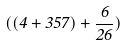Convert formula to latex. <formula><loc_0><loc_0><loc_500><loc_500>( ( 4 + 3 5 7 ) + \frac { 6 } { 2 6 } )</formula> 